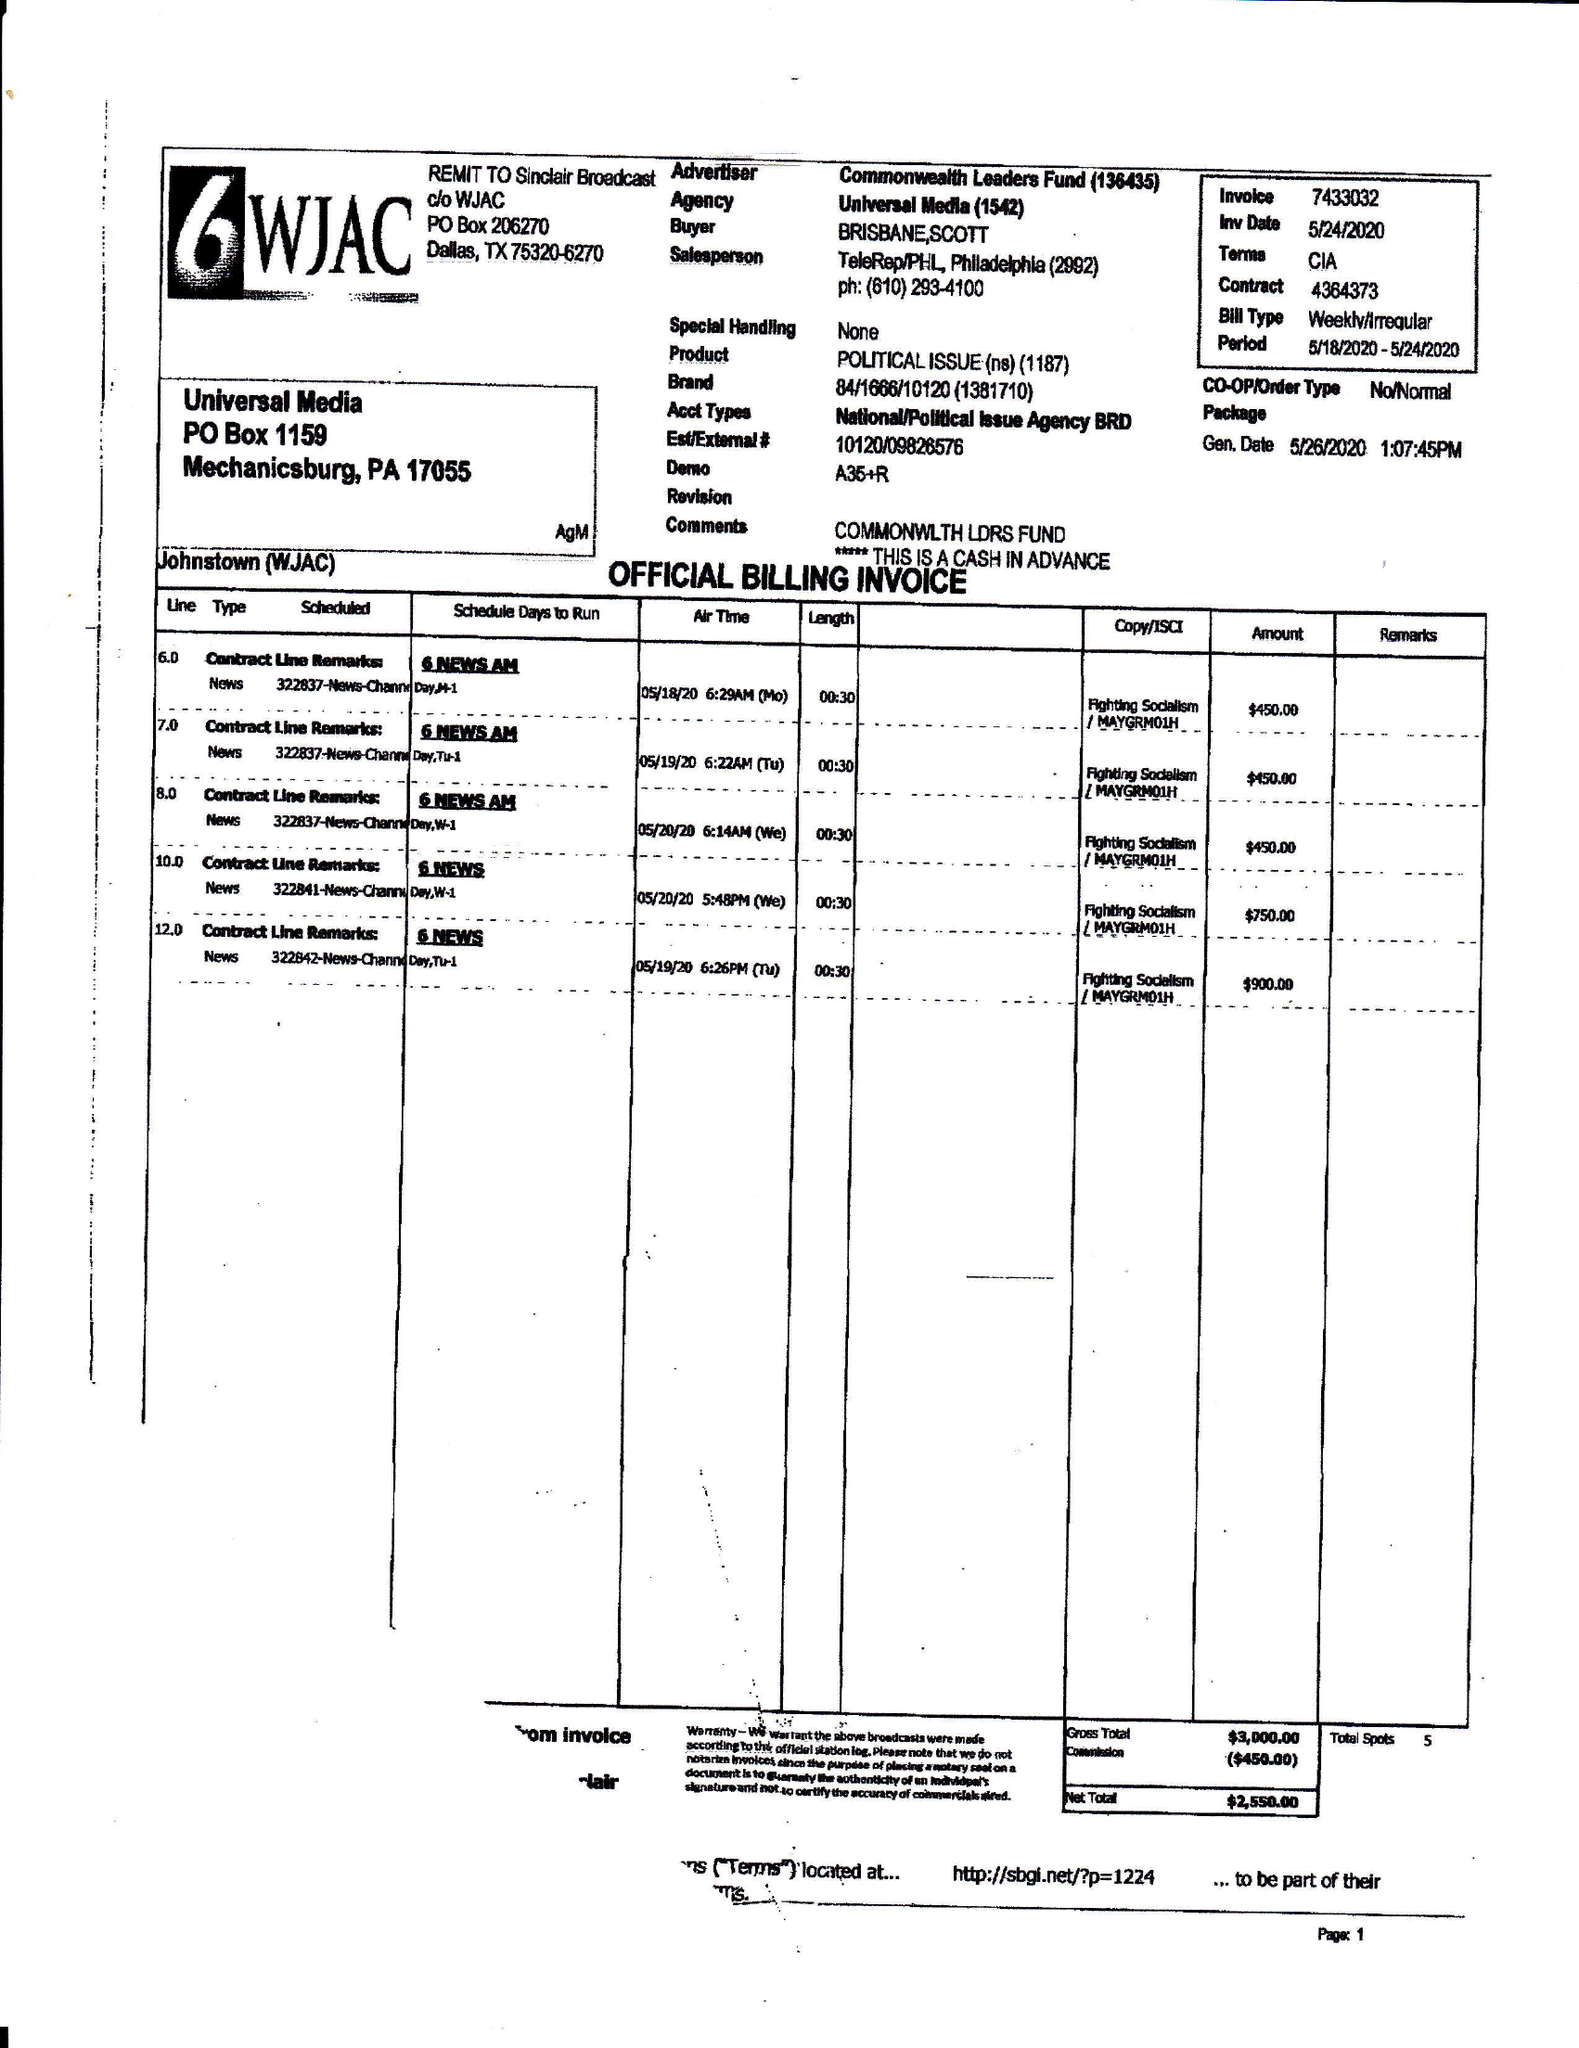What is the value for the flight_from?
Answer the question using a single word or phrase. 05/18/20 